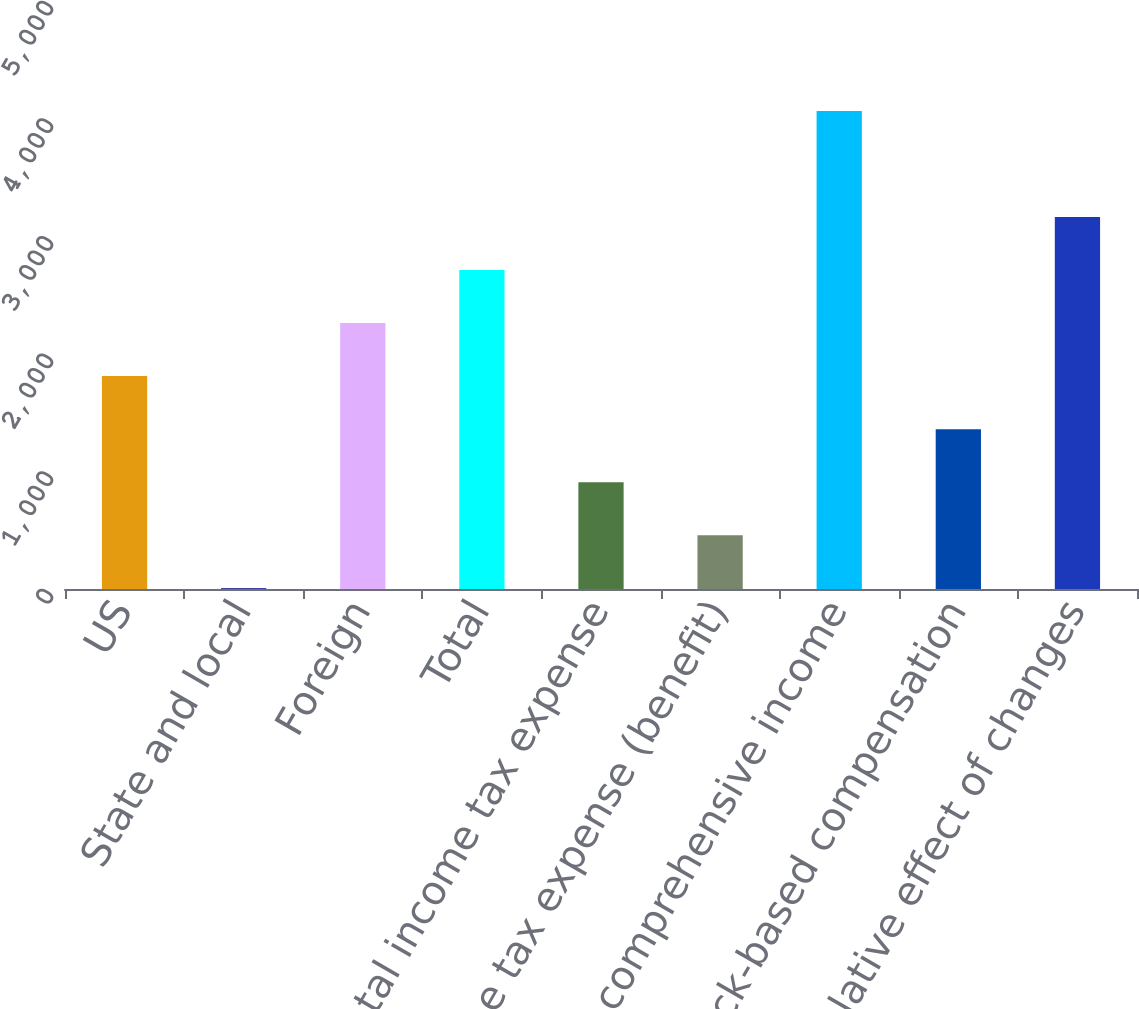<chart> <loc_0><loc_0><loc_500><loc_500><bar_chart><fcel>US<fcel>State and local<fcel>Foreign<fcel>Total<fcel>Total income tax expense<fcel>Income tax expense (benefit)<fcel>Other comprehensive income<fcel>Stock-based compensation<fcel>Cumulative effect of changes<nl><fcel>1810.2<fcel>7<fcel>2261<fcel>2711.8<fcel>908.6<fcel>457.8<fcel>4064.2<fcel>1359.4<fcel>3162.6<nl></chart> 